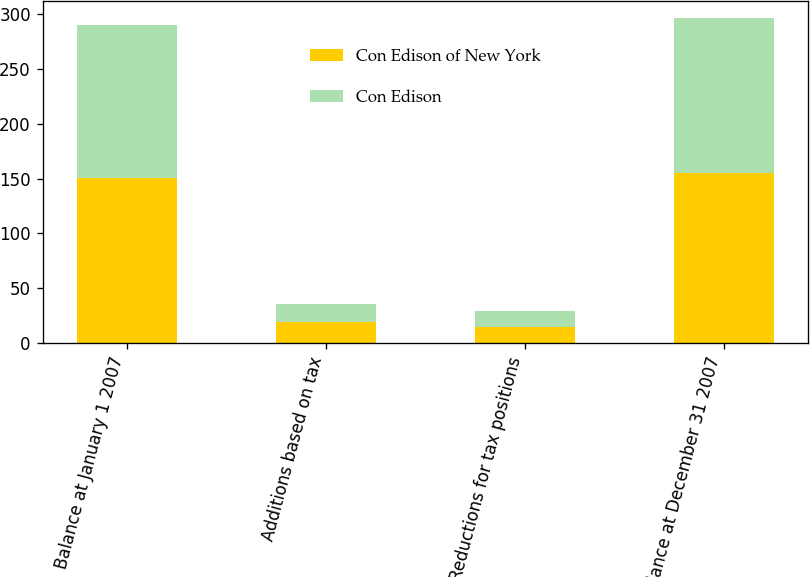<chart> <loc_0><loc_0><loc_500><loc_500><stacked_bar_chart><ecel><fcel>Balance at January 1 2007<fcel>Additions based on tax<fcel>Reductions for tax positions<fcel>Balance at December 31 2007<nl><fcel>Con Edison of New York<fcel>151<fcel>19<fcel>15<fcel>155<nl><fcel>Con Edison<fcel>139<fcel>17<fcel>14<fcel>142<nl></chart> 